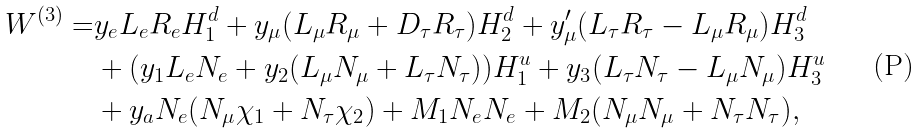<formula> <loc_0><loc_0><loc_500><loc_500>W ^ { ( 3 ) } = & y _ { e } L _ { e } R _ { e } H ^ { d } _ { 1 } + y _ { \mu } ( L _ { \mu } R _ { \mu } + D _ { \tau } R _ { \tau } ) H ^ { d } _ { 2 } + y ^ { \prime } _ { \mu } ( L _ { \tau } R _ { \tau } - L _ { \mu } R _ { \mu } ) H ^ { d } _ { 3 } \\ & + ( y _ { 1 } L _ { e } N _ { e } + y _ { 2 } ( L _ { \mu } N _ { \mu } + L _ { \tau } N _ { \tau } ) ) H _ { 1 } ^ { u } + y _ { 3 } ( L _ { \tau } N _ { \tau } - L _ { \mu } N _ { \mu } ) H ^ { u } _ { 3 } \\ & + y _ { a } N _ { e } ( N _ { \mu } \chi _ { 1 } + N _ { \tau } \chi _ { 2 } ) + M _ { 1 } N _ { e } N _ { e } + M _ { 2 } ( N _ { \mu } N _ { \mu } + N _ { \tau } N _ { \tau } ) ,</formula> 